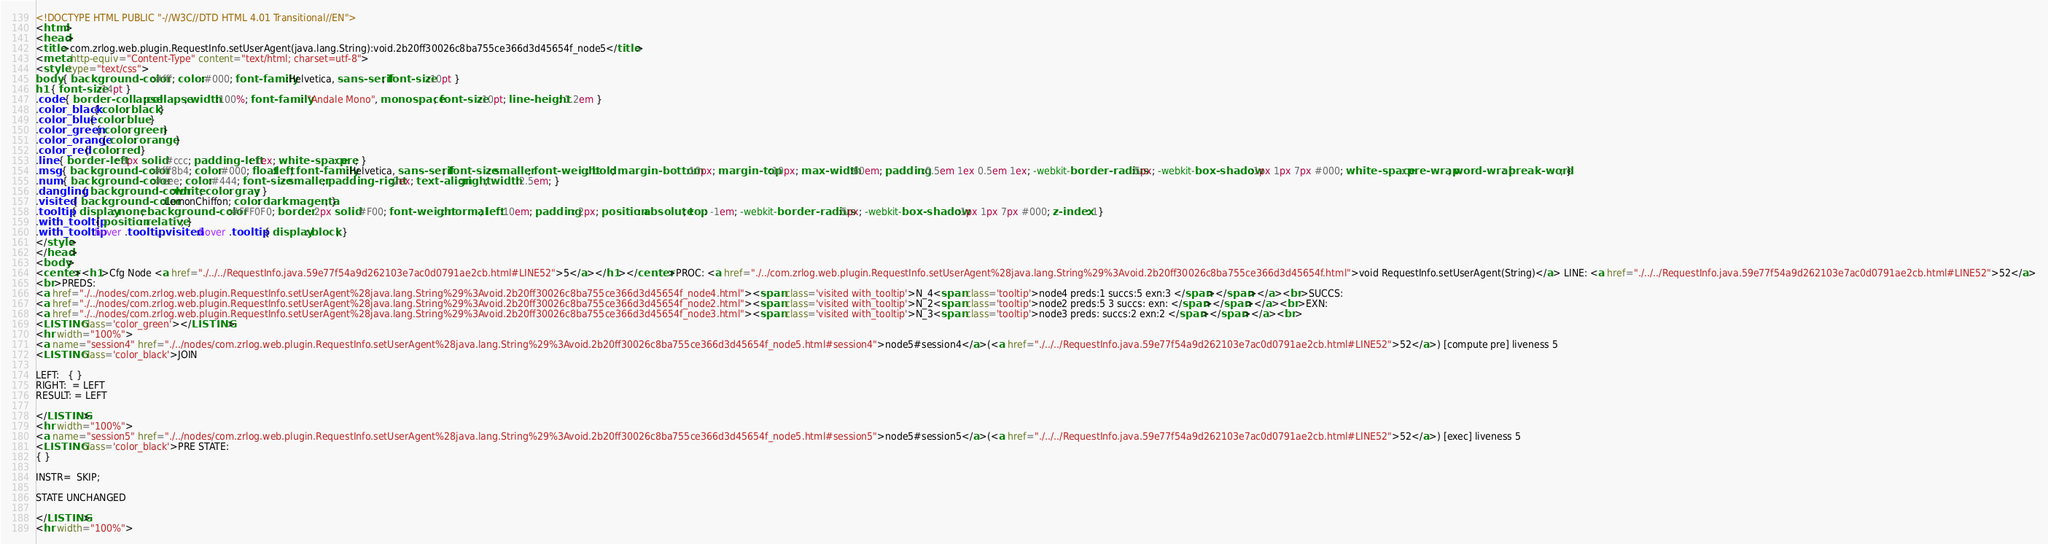Convert code to text. <code><loc_0><loc_0><loc_500><loc_500><_HTML_><!DOCTYPE HTML PUBLIC "-//W3C//DTD HTML 4.01 Transitional//EN">
<html>
<head>
<title>com.zrlog.web.plugin.RequestInfo.setUserAgent(java.lang.String):void.2b20ff30026c8ba755ce366d3d45654f_node5</title>
<meta http-equiv="Content-Type" content="text/html; charset=utf-8">
<style type="text/css">
body { background-color:#fff; color:#000; font-family:Helvetica, sans-serif; font-size:10pt }
h1 { font-size:14pt }
.code { border-collapse:collapse; width:100%; font-family: "Andale Mono", monospace; font-size:10pt; line-height: 1.2em }
.color_black { color: black }
.color_blue { color: blue }
.color_green { color: green }
.color_orange { color: orange }
.color_red { color: red }
.line { border-left: 3px solid #ccc; padding-left: 1ex; white-space: pre; }
.msg { background-color:#fff8b4; color:#000; float:left; font-family:Helvetica, sans-serif; font-size: smaller; font-weight: bold; margin-bottom:10px; margin-top:10px; max-width:60em; padding:0.5em 1ex 0.5em 1ex; -webkit-border-radius:5px; -webkit-box-shadow:1px 1px 7px #000; white-space: pre-wrap; word-wrap: break-word; }
.num { background-color:#eee; color:#444; font-size: smaller; padding-right:2ex; text-align:right; width:2.5em; }
.dangling { background-color:white; color: gray; }
.visited { background-color:LemonChiffon; color: darkmagenta; }
.tooltip { display: none; background-color:#FFF0F0; border: 2px solid #F00; font-weight: normal; left:10em; padding: 2px; position: absolute; top: -1em; -webkit-border-radius:5px; -webkit-box-shadow:1px 1px 7px #000; z-index: 1}
.with_tooltip { position: relative; }
.with_tooltip:hover .tooltip, .visited:hover .tooltip { display: block; }
</style>
</head>
<body>
<center><h1>Cfg Node <a href="./../../RequestInfo.java.59e77f54a9d262103e7ac0d0791ae2cb.html#LINE52">5</a></h1></center>PROC: <a href="./../com.zrlog.web.plugin.RequestInfo.setUserAgent%28java.lang.String%29%3Avoid.2b20ff30026c8ba755ce366d3d45654f.html">void RequestInfo.setUserAgent(String)</a> LINE: <a href="./../../RequestInfo.java.59e77f54a9d262103e7ac0d0791ae2cb.html#LINE52">52</a>
<br>PREDS:
<a href="./../nodes/com.zrlog.web.plugin.RequestInfo.setUserAgent%28java.lang.String%29%3Avoid.2b20ff30026c8ba755ce366d3d45654f_node4.html"><span class='visited with_tooltip'>N_4<span class='tooltip'>node4 preds:1 succs:5 exn:3 </span></span></a><br>SUCCS:
<a href="./../nodes/com.zrlog.web.plugin.RequestInfo.setUserAgent%28java.lang.String%29%3Avoid.2b20ff30026c8ba755ce366d3d45654f_node2.html"><span class='visited with_tooltip'>N_2<span class='tooltip'>node2 preds:5 3 succs: exn: </span></span></a><br>EXN:
<a href="./../nodes/com.zrlog.web.plugin.RequestInfo.setUserAgent%28java.lang.String%29%3Avoid.2b20ff30026c8ba755ce366d3d45654f_node3.html"><span class='visited with_tooltip'>N_3<span class='tooltip'>node3 preds: succs:2 exn:2 </span></span></a><br>
<LISTING class='color_green'></LISTING>
<hr width="100%">
<a name="session4" href="./../nodes/com.zrlog.web.plugin.RequestInfo.setUserAgent%28java.lang.String%29%3Avoid.2b20ff30026c8ba755ce366d3d45654f_node5.html#session4">node5#session4</a>(<a href="./../../RequestInfo.java.59e77f54a9d262103e7ac0d0791ae2cb.html#LINE52">52</a>) [compute pre] liveness 5
<LISTING class='color_black'>JOIN

LEFT:   { }
RIGHT:  = LEFT
RESULT: = LEFT

</LISTING>
<hr width="100%">
<a name="session5" href="./../nodes/com.zrlog.web.plugin.RequestInfo.setUserAgent%28java.lang.String%29%3Avoid.2b20ff30026c8ba755ce366d3d45654f_node5.html#session5">node5#session5</a>(<a href="./../../RequestInfo.java.59e77f54a9d262103e7ac0d0791ae2cb.html#LINE52">52</a>) [exec] liveness 5
<LISTING class='color_black'>PRE STATE:
{ }

INSTR=  SKIP; 

STATE UNCHANGED

</LISTING>
<hr width="100%"></code> 